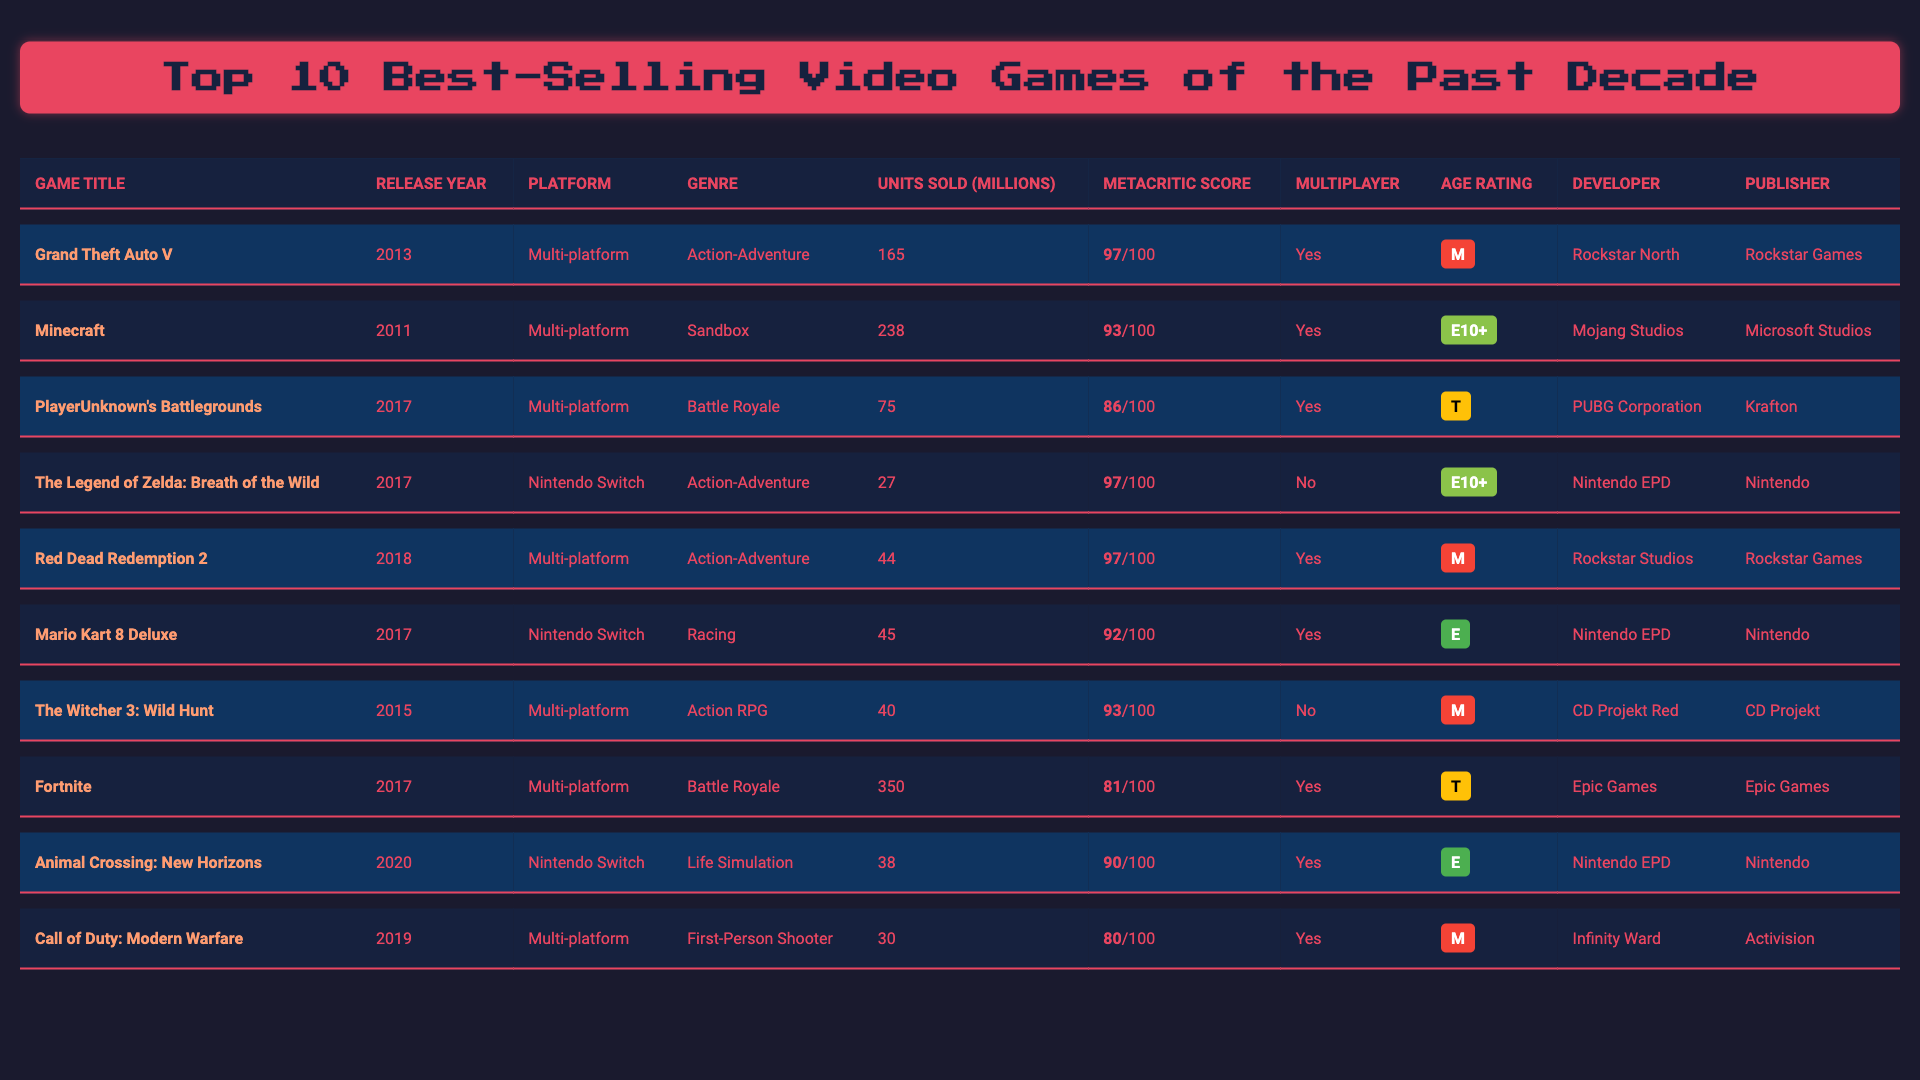What is the best-selling video game of the past decade? The table shows that "Minecraft" has the highest units sold at 238 million, making it the best-selling video game in the list.
Answer: Minecraft How many units did "Grand Theft Auto V" sell? The table indicates that "Grand Theft Auto V" sold 165 million units, as represented in the data for that game.
Answer: 165 million Which game has the highest Metacritic score? By examining the Metacritic scores in the table, both "Grand Theft Auto V," "The Legend of Zelda: Breath of the Wild," and "Red Dead Redemption 2" scored 97, which is the highest.
Answer: Grand Theft Auto V, The Legend of Zelda: Breath of the Wild, Red Dead Redemption 2 What percentage of units sold does "Fortnite" represent compared to "Minecraft"? "Fortnite" sold 350 million units and "Minecraft" sold 238 million units. To find the percentage, divide Fortnite's units by Minecraft's units and multiply by 100: (350/238) × 100 ≈ 147.0%.
Answer: Approximately 147.0% Is "Animal Crossing: New Horizons" a multiplayer game? The table shows that "Animal Crossing: New Horizons" has "Yes" listed under the multiplayer column, indicating it does have multiplayer capabilities.
Answer: Yes How many games have an age rating of "E"? By checking the age rating column, we can see that there are three games: "Minecraft," "Mario Kart 8 Deluxe," and "Animal Crossing: New Horizons."
Answer: 3 What is the average units sold of the listed games? To find the average, we sum the units sold: 238 + 165 + 75 + 27 + 44 + 45 + 40 + 350 + 38 + 30 = 1052 million. Then, divide by the number of games (10), resulting in an average of 105.2 million units sold.
Answer: 105.2 million Which game had the highest sales in the year of its release? By checking the table, "Minecraft" was released in 2011 and had the highest sales of 238 million; other games had lower sales figures at their release.
Answer: Minecraft How many games were released in 2017? The table reveals that there are four games released in 2017: "PlayerUnknown's Battlegrounds," "The Legend of Zelda: Breath of the Wild," "Mario Kart 8 Deluxe," and "Fortnite."
Answer: 4 Which developer created "Red Dead Redemption 2"? According to the table, "Red Dead Redemption 2" was developed by "Rockstar Studios," as listed in the developer column.
Answer: Rockstar Studios 